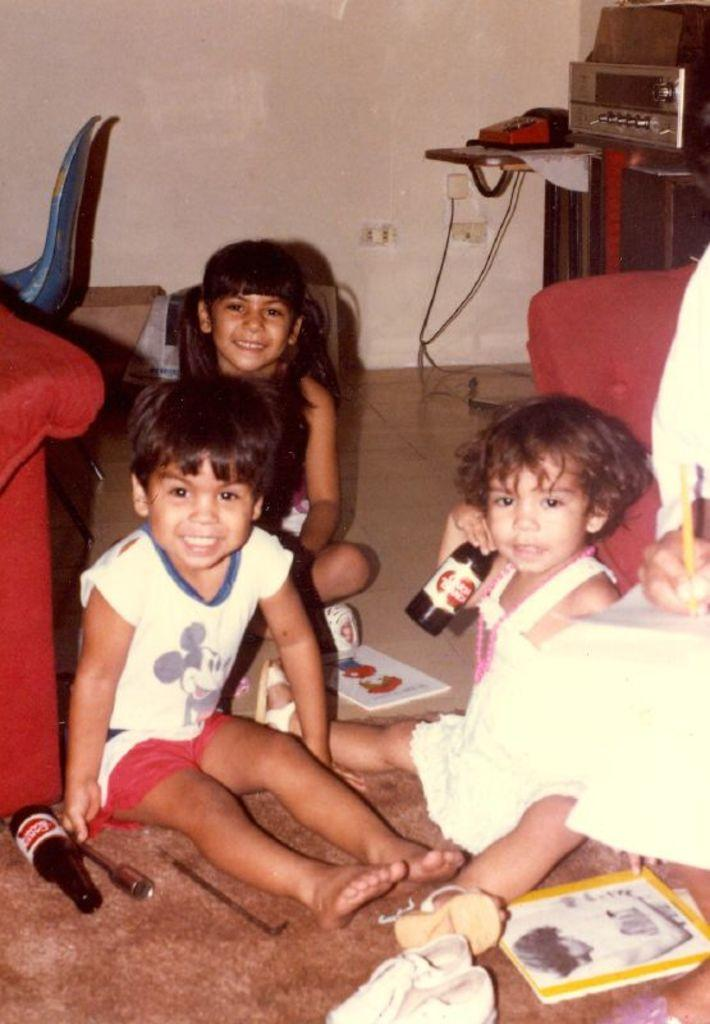What are the children in the image doing? The children are sitting on the floor in the image. What can be seen in the background of the image? There is a book, chairs, bottles, and a telephone in the background of the image. What type of crime is being committed in the image? There is no crime being committed in the image; it simply shows children sitting on the floor and various objects in the background. 